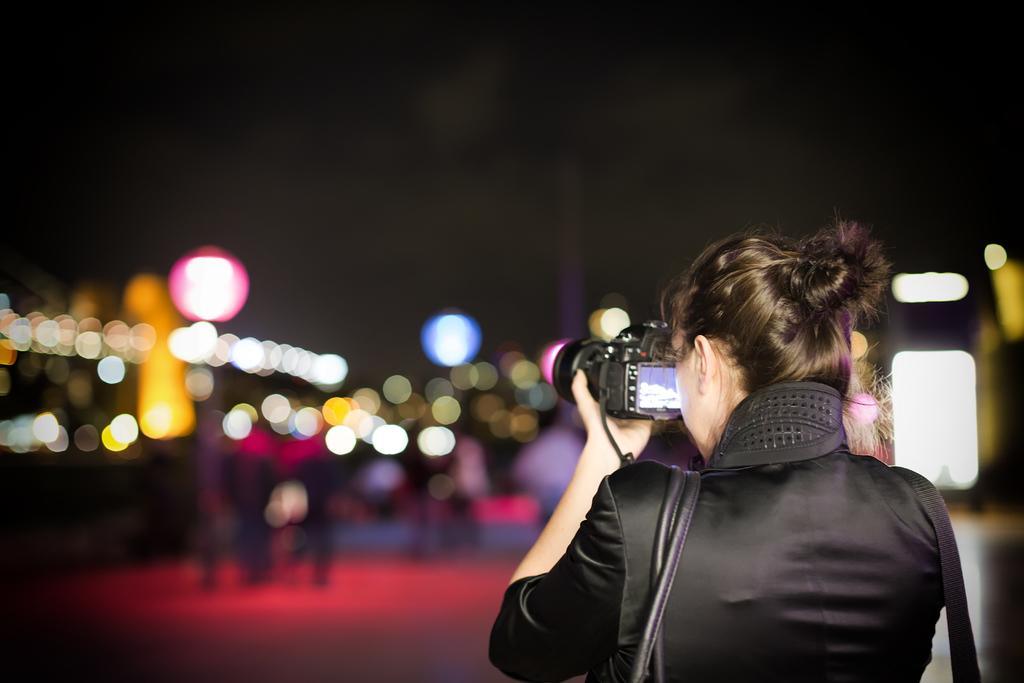Please provide a concise description of this image. In this image there woman holding a camera and the woman is wearing a bag. 